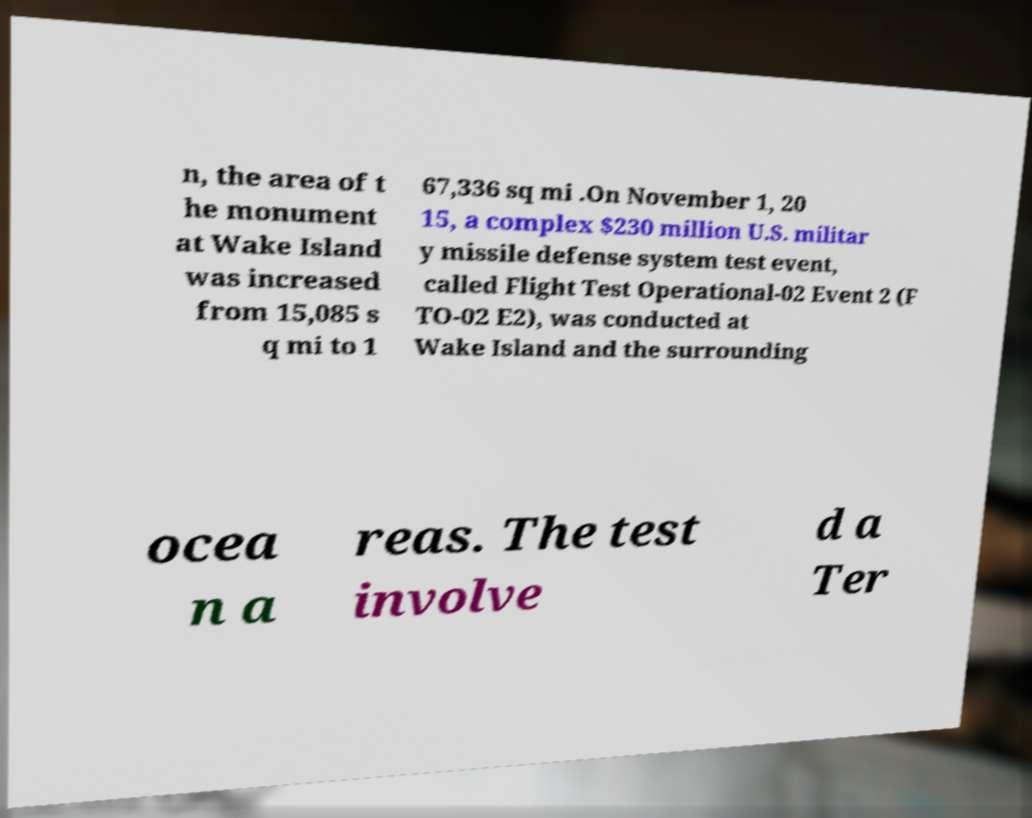Please identify and transcribe the text found in this image. n, the area of t he monument at Wake Island was increased from 15,085 s q mi to 1 67,336 sq mi .On November 1, 20 15, a complex $230 million U.S. militar y missile defense system test event, called Flight Test Operational-02 Event 2 (F TO-02 E2), was conducted at Wake Island and the surrounding ocea n a reas. The test involve d a Ter 